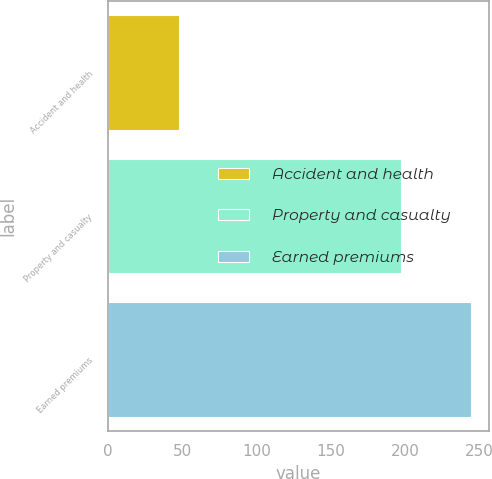Convert chart to OTSL. <chart><loc_0><loc_0><loc_500><loc_500><bar_chart><fcel>Accident and health<fcel>Property and casualty<fcel>Earned premiums<nl><fcel>48<fcel>197<fcel>244<nl></chart> 